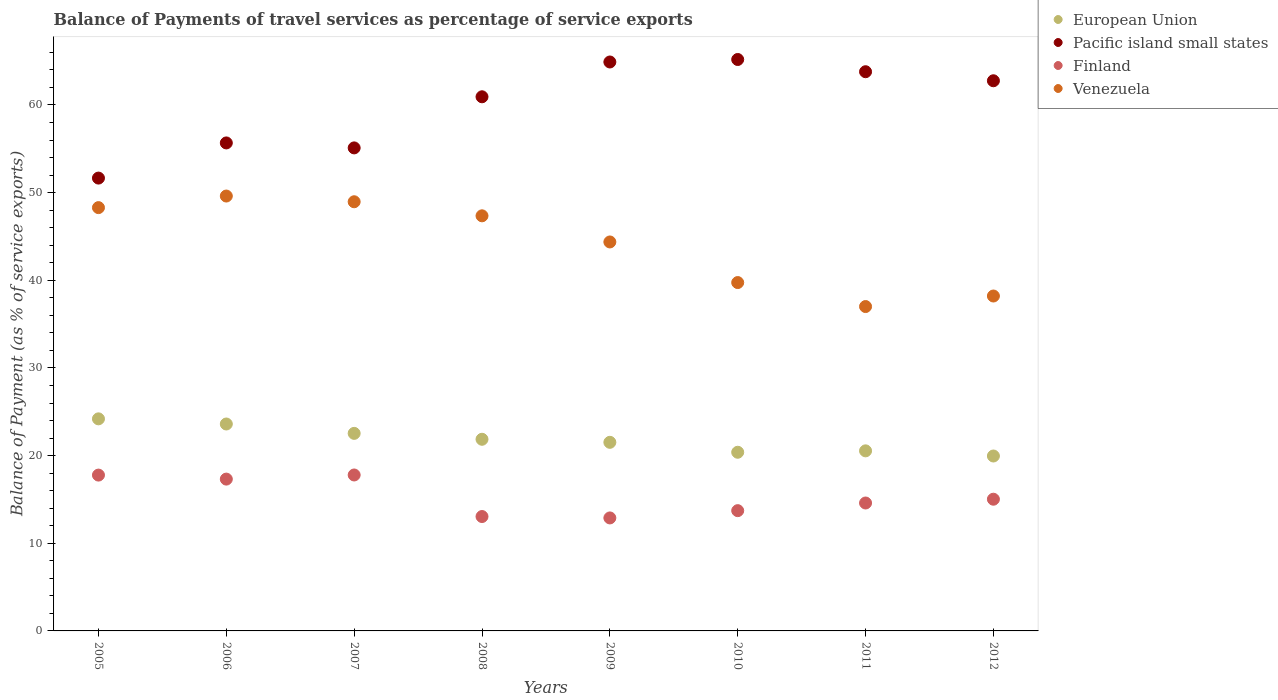How many different coloured dotlines are there?
Your answer should be very brief. 4. What is the balance of payments of travel services in European Union in 2011?
Ensure brevity in your answer.  20.54. Across all years, what is the maximum balance of payments of travel services in Venezuela?
Ensure brevity in your answer.  49.61. Across all years, what is the minimum balance of payments of travel services in Finland?
Offer a terse response. 12.89. What is the total balance of payments of travel services in Finland in the graph?
Ensure brevity in your answer.  122.17. What is the difference between the balance of payments of travel services in Venezuela in 2008 and that in 2009?
Your answer should be compact. 2.98. What is the difference between the balance of payments of travel services in European Union in 2011 and the balance of payments of travel services in Finland in 2012?
Keep it short and to the point. 5.52. What is the average balance of payments of travel services in Venezuela per year?
Ensure brevity in your answer.  44.19. In the year 2007, what is the difference between the balance of payments of travel services in Venezuela and balance of payments of travel services in European Union?
Your answer should be compact. 26.42. In how many years, is the balance of payments of travel services in European Union greater than 46 %?
Give a very brief answer. 0. What is the ratio of the balance of payments of travel services in European Union in 2008 to that in 2009?
Ensure brevity in your answer.  1.02. Is the balance of payments of travel services in Venezuela in 2007 less than that in 2012?
Your answer should be compact. No. What is the difference between the highest and the second highest balance of payments of travel services in European Union?
Your answer should be very brief. 0.59. What is the difference between the highest and the lowest balance of payments of travel services in European Union?
Provide a short and direct response. 4.24. Is the sum of the balance of payments of travel services in Pacific island small states in 2010 and 2012 greater than the maximum balance of payments of travel services in European Union across all years?
Your answer should be compact. Yes. Is the balance of payments of travel services in Pacific island small states strictly less than the balance of payments of travel services in European Union over the years?
Keep it short and to the point. No. Does the graph contain any zero values?
Offer a very short reply. No. Does the graph contain grids?
Provide a succinct answer. No. Where does the legend appear in the graph?
Ensure brevity in your answer.  Top right. What is the title of the graph?
Provide a short and direct response. Balance of Payments of travel services as percentage of service exports. Does "Uzbekistan" appear as one of the legend labels in the graph?
Your answer should be compact. No. What is the label or title of the Y-axis?
Offer a very short reply. Balance of Payment (as % of service exports). What is the Balance of Payment (as % of service exports) in European Union in 2005?
Your answer should be very brief. 24.19. What is the Balance of Payment (as % of service exports) in Pacific island small states in 2005?
Provide a short and direct response. 51.66. What is the Balance of Payment (as % of service exports) of Finland in 2005?
Provide a short and direct response. 17.78. What is the Balance of Payment (as % of service exports) in Venezuela in 2005?
Ensure brevity in your answer.  48.29. What is the Balance of Payment (as % of service exports) of European Union in 2006?
Provide a short and direct response. 23.61. What is the Balance of Payment (as % of service exports) of Pacific island small states in 2006?
Give a very brief answer. 55.67. What is the Balance of Payment (as % of service exports) in Finland in 2006?
Provide a succinct answer. 17.32. What is the Balance of Payment (as % of service exports) in Venezuela in 2006?
Make the answer very short. 49.61. What is the Balance of Payment (as % of service exports) in European Union in 2007?
Your answer should be compact. 22.54. What is the Balance of Payment (as % of service exports) of Pacific island small states in 2007?
Offer a very short reply. 55.1. What is the Balance of Payment (as % of service exports) of Finland in 2007?
Provide a short and direct response. 17.79. What is the Balance of Payment (as % of service exports) of Venezuela in 2007?
Ensure brevity in your answer.  48.96. What is the Balance of Payment (as % of service exports) of European Union in 2008?
Offer a terse response. 21.86. What is the Balance of Payment (as % of service exports) in Pacific island small states in 2008?
Ensure brevity in your answer.  60.94. What is the Balance of Payment (as % of service exports) of Finland in 2008?
Your answer should be very brief. 13.05. What is the Balance of Payment (as % of service exports) in Venezuela in 2008?
Provide a succinct answer. 47.36. What is the Balance of Payment (as % of service exports) in European Union in 2009?
Your response must be concise. 21.52. What is the Balance of Payment (as % of service exports) of Pacific island small states in 2009?
Your response must be concise. 64.91. What is the Balance of Payment (as % of service exports) in Finland in 2009?
Your answer should be very brief. 12.89. What is the Balance of Payment (as % of service exports) of Venezuela in 2009?
Keep it short and to the point. 44.37. What is the Balance of Payment (as % of service exports) in European Union in 2010?
Offer a very short reply. 20.38. What is the Balance of Payment (as % of service exports) in Pacific island small states in 2010?
Ensure brevity in your answer.  65.19. What is the Balance of Payment (as % of service exports) in Finland in 2010?
Ensure brevity in your answer.  13.72. What is the Balance of Payment (as % of service exports) of Venezuela in 2010?
Offer a terse response. 39.74. What is the Balance of Payment (as % of service exports) in European Union in 2011?
Give a very brief answer. 20.54. What is the Balance of Payment (as % of service exports) of Pacific island small states in 2011?
Ensure brevity in your answer.  63.8. What is the Balance of Payment (as % of service exports) in Finland in 2011?
Your answer should be compact. 14.59. What is the Balance of Payment (as % of service exports) of Venezuela in 2011?
Your response must be concise. 37.01. What is the Balance of Payment (as % of service exports) in European Union in 2012?
Your answer should be compact. 19.96. What is the Balance of Payment (as % of service exports) of Pacific island small states in 2012?
Give a very brief answer. 62.76. What is the Balance of Payment (as % of service exports) in Finland in 2012?
Your answer should be very brief. 15.03. What is the Balance of Payment (as % of service exports) in Venezuela in 2012?
Your answer should be compact. 38.21. Across all years, what is the maximum Balance of Payment (as % of service exports) in European Union?
Ensure brevity in your answer.  24.19. Across all years, what is the maximum Balance of Payment (as % of service exports) of Pacific island small states?
Provide a short and direct response. 65.19. Across all years, what is the maximum Balance of Payment (as % of service exports) of Finland?
Ensure brevity in your answer.  17.79. Across all years, what is the maximum Balance of Payment (as % of service exports) in Venezuela?
Give a very brief answer. 49.61. Across all years, what is the minimum Balance of Payment (as % of service exports) in European Union?
Make the answer very short. 19.96. Across all years, what is the minimum Balance of Payment (as % of service exports) in Pacific island small states?
Give a very brief answer. 51.66. Across all years, what is the minimum Balance of Payment (as % of service exports) of Finland?
Offer a terse response. 12.89. Across all years, what is the minimum Balance of Payment (as % of service exports) in Venezuela?
Give a very brief answer. 37.01. What is the total Balance of Payment (as % of service exports) in European Union in the graph?
Offer a very short reply. 174.6. What is the total Balance of Payment (as % of service exports) in Pacific island small states in the graph?
Your answer should be compact. 480.03. What is the total Balance of Payment (as % of service exports) of Finland in the graph?
Your answer should be very brief. 122.17. What is the total Balance of Payment (as % of service exports) of Venezuela in the graph?
Make the answer very short. 353.55. What is the difference between the Balance of Payment (as % of service exports) of European Union in 2005 and that in 2006?
Offer a very short reply. 0.59. What is the difference between the Balance of Payment (as % of service exports) in Pacific island small states in 2005 and that in 2006?
Your answer should be very brief. -4.01. What is the difference between the Balance of Payment (as % of service exports) of Finland in 2005 and that in 2006?
Your response must be concise. 0.46. What is the difference between the Balance of Payment (as % of service exports) of Venezuela in 2005 and that in 2006?
Your answer should be compact. -1.32. What is the difference between the Balance of Payment (as % of service exports) of European Union in 2005 and that in 2007?
Make the answer very short. 1.66. What is the difference between the Balance of Payment (as % of service exports) of Pacific island small states in 2005 and that in 2007?
Offer a very short reply. -3.44. What is the difference between the Balance of Payment (as % of service exports) in Finland in 2005 and that in 2007?
Provide a succinct answer. -0.01. What is the difference between the Balance of Payment (as % of service exports) in Venezuela in 2005 and that in 2007?
Ensure brevity in your answer.  -0.67. What is the difference between the Balance of Payment (as % of service exports) of European Union in 2005 and that in 2008?
Your answer should be very brief. 2.33. What is the difference between the Balance of Payment (as % of service exports) of Pacific island small states in 2005 and that in 2008?
Provide a short and direct response. -9.27. What is the difference between the Balance of Payment (as % of service exports) in Finland in 2005 and that in 2008?
Provide a succinct answer. 4.73. What is the difference between the Balance of Payment (as % of service exports) in Venezuela in 2005 and that in 2008?
Give a very brief answer. 0.93. What is the difference between the Balance of Payment (as % of service exports) in European Union in 2005 and that in 2009?
Offer a very short reply. 2.68. What is the difference between the Balance of Payment (as % of service exports) of Pacific island small states in 2005 and that in 2009?
Offer a very short reply. -13.24. What is the difference between the Balance of Payment (as % of service exports) in Finland in 2005 and that in 2009?
Your response must be concise. 4.89. What is the difference between the Balance of Payment (as % of service exports) of Venezuela in 2005 and that in 2009?
Offer a very short reply. 3.92. What is the difference between the Balance of Payment (as % of service exports) in European Union in 2005 and that in 2010?
Your answer should be very brief. 3.81. What is the difference between the Balance of Payment (as % of service exports) in Pacific island small states in 2005 and that in 2010?
Offer a very short reply. -13.53. What is the difference between the Balance of Payment (as % of service exports) in Finland in 2005 and that in 2010?
Provide a short and direct response. 4.06. What is the difference between the Balance of Payment (as % of service exports) in Venezuela in 2005 and that in 2010?
Provide a short and direct response. 8.55. What is the difference between the Balance of Payment (as % of service exports) in European Union in 2005 and that in 2011?
Keep it short and to the point. 3.65. What is the difference between the Balance of Payment (as % of service exports) in Pacific island small states in 2005 and that in 2011?
Offer a very short reply. -12.13. What is the difference between the Balance of Payment (as % of service exports) of Finland in 2005 and that in 2011?
Keep it short and to the point. 3.18. What is the difference between the Balance of Payment (as % of service exports) in Venezuela in 2005 and that in 2011?
Your answer should be very brief. 11.29. What is the difference between the Balance of Payment (as % of service exports) of European Union in 2005 and that in 2012?
Provide a short and direct response. 4.24. What is the difference between the Balance of Payment (as % of service exports) in Pacific island small states in 2005 and that in 2012?
Make the answer very short. -11.1. What is the difference between the Balance of Payment (as % of service exports) of Finland in 2005 and that in 2012?
Keep it short and to the point. 2.75. What is the difference between the Balance of Payment (as % of service exports) in Venezuela in 2005 and that in 2012?
Make the answer very short. 10.08. What is the difference between the Balance of Payment (as % of service exports) of European Union in 2006 and that in 2007?
Your answer should be very brief. 1.07. What is the difference between the Balance of Payment (as % of service exports) of Pacific island small states in 2006 and that in 2007?
Your answer should be very brief. 0.57. What is the difference between the Balance of Payment (as % of service exports) of Finland in 2006 and that in 2007?
Provide a short and direct response. -0.47. What is the difference between the Balance of Payment (as % of service exports) of Venezuela in 2006 and that in 2007?
Offer a terse response. 0.65. What is the difference between the Balance of Payment (as % of service exports) in European Union in 2006 and that in 2008?
Give a very brief answer. 1.74. What is the difference between the Balance of Payment (as % of service exports) in Pacific island small states in 2006 and that in 2008?
Your answer should be compact. -5.26. What is the difference between the Balance of Payment (as % of service exports) of Finland in 2006 and that in 2008?
Keep it short and to the point. 4.27. What is the difference between the Balance of Payment (as % of service exports) of Venezuela in 2006 and that in 2008?
Ensure brevity in your answer.  2.26. What is the difference between the Balance of Payment (as % of service exports) in European Union in 2006 and that in 2009?
Your response must be concise. 2.09. What is the difference between the Balance of Payment (as % of service exports) in Pacific island small states in 2006 and that in 2009?
Ensure brevity in your answer.  -9.23. What is the difference between the Balance of Payment (as % of service exports) of Finland in 2006 and that in 2009?
Offer a terse response. 4.43. What is the difference between the Balance of Payment (as % of service exports) of Venezuela in 2006 and that in 2009?
Offer a very short reply. 5.24. What is the difference between the Balance of Payment (as % of service exports) of European Union in 2006 and that in 2010?
Ensure brevity in your answer.  3.22. What is the difference between the Balance of Payment (as % of service exports) of Pacific island small states in 2006 and that in 2010?
Your response must be concise. -9.52. What is the difference between the Balance of Payment (as % of service exports) of Finland in 2006 and that in 2010?
Your answer should be compact. 3.6. What is the difference between the Balance of Payment (as % of service exports) in Venezuela in 2006 and that in 2010?
Offer a very short reply. 9.87. What is the difference between the Balance of Payment (as % of service exports) in European Union in 2006 and that in 2011?
Offer a very short reply. 3.06. What is the difference between the Balance of Payment (as % of service exports) of Pacific island small states in 2006 and that in 2011?
Keep it short and to the point. -8.12. What is the difference between the Balance of Payment (as % of service exports) of Finland in 2006 and that in 2011?
Keep it short and to the point. 2.73. What is the difference between the Balance of Payment (as % of service exports) of Venezuela in 2006 and that in 2011?
Make the answer very short. 12.61. What is the difference between the Balance of Payment (as % of service exports) in European Union in 2006 and that in 2012?
Your response must be concise. 3.65. What is the difference between the Balance of Payment (as % of service exports) of Pacific island small states in 2006 and that in 2012?
Keep it short and to the point. -7.09. What is the difference between the Balance of Payment (as % of service exports) in Finland in 2006 and that in 2012?
Keep it short and to the point. 2.29. What is the difference between the Balance of Payment (as % of service exports) of Venezuela in 2006 and that in 2012?
Provide a short and direct response. 11.41. What is the difference between the Balance of Payment (as % of service exports) in European Union in 2007 and that in 2008?
Give a very brief answer. 0.67. What is the difference between the Balance of Payment (as % of service exports) of Pacific island small states in 2007 and that in 2008?
Offer a terse response. -5.83. What is the difference between the Balance of Payment (as % of service exports) in Finland in 2007 and that in 2008?
Your answer should be very brief. 4.74. What is the difference between the Balance of Payment (as % of service exports) in Venezuela in 2007 and that in 2008?
Your response must be concise. 1.6. What is the difference between the Balance of Payment (as % of service exports) in European Union in 2007 and that in 2009?
Provide a succinct answer. 1.02. What is the difference between the Balance of Payment (as % of service exports) of Pacific island small states in 2007 and that in 2009?
Give a very brief answer. -9.8. What is the difference between the Balance of Payment (as % of service exports) of Finland in 2007 and that in 2009?
Provide a succinct answer. 4.9. What is the difference between the Balance of Payment (as % of service exports) in Venezuela in 2007 and that in 2009?
Your answer should be very brief. 4.59. What is the difference between the Balance of Payment (as % of service exports) in European Union in 2007 and that in 2010?
Ensure brevity in your answer.  2.15. What is the difference between the Balance of Payment (as % of service exports) in Pacific island small states in 2007 and that in 2010?
Ensure brevity in your answer.  -10.09. What is the difference between the Balance of Payment (as % of service exports) of Finland in 2007 and that in 2010?
Offer a terse response. 4.07. What is the difference between the Balance of Payment (as % of service exports) of Venezuela in 2007 and that in 2010?
Give a very brief answer. 9.22. What is the difference between the Balance of Payment (as % of service exports) in European Union in 2007 and that in 2011?
Offer a very short reply. 1.99. What is the difference between the Balance of Payment (as % of service exports) of Pacific island small states in 2007 and that in 2011?
Provide a short and direct response. -8.69. What is the difference between the Balance of Payment (as % of service exports) of Finland in 2007 and that in 2011?
Keep it short and to the point. 3.2. What is the difference between the Balance of Payment (as % of service exports) in Venezuela in 2007 and that in 2011?
Ensure brevity in your answer.  11.96. What is the difference between the Balance of Payment (as % of service exports) of European Union in 2007 and that in 2012?
Provide a short and direct response. 2.58. What is the difference between the Balance of Payment (as % of service exports) in Pacific island small states in 2007 and that in 2012?
Provide a short and direct response. -7.66. What is the difference between the Balance of Payment (as % of service exports) of Finland in 2007 and that in 2012?
Your answer should be compact. 2.76. What is the difference between the Balance of Payment (as % of service exports) of Venezuela in 2007 and that in 2012?
Your answer should be compact. 10.75. What is the difference between the Balance of Payment (as % of service exports) of European Union in 2008 and that in 2009?
Provide a short and direct response. 0.35. What is the difference between the Balance of Payment (as % of service exports) in Pacific island small states in 2008 and that in 2009?
Your answer should be compact. -3.97. What is the difference between the Balance of Payment (as % of service exports) of Finland in 2008 and that in 2009?
Provide a succinct answer. 0.16. What is the difference between the Balance of Payment (as % of service exports) in Venezuela in 2008 and that in 2009?
Keep it short and to the point. 2.98. What is the difference between the Balance of Payment (as % of service exports) in European Union in 2008 and that in 2010?
Offer a terse response. 1.48. What is the difference between the Balance of Payment (as % of service exports) of Pacific island small states in 2008 and that in 2010?
Ensure brevity in your answer.  -4.25. What is the difference between the Balance of Payment (as % of service exports) of Finland in 2008 and that in 2010?
Your answer should be very brief. -0.67. What is the difference between the Balance of Payment (as % of service exports) in Venezuela in 2008 and that in 2010?
Your answer should be compact. 7.61. What is the difference between the Balance of Payment (as % of service exports) of European Union in 2008 and that in 2011?
Offer a very short reply. 1.32. What is the difference between the Balance of Payment (as % of service exports) in Pacific island small states in 2008 and that in 2011?
Ensure brevity in your answer.  -2.86. What is the difference between the Balance of Payment (as % of service exports) in Finland in 2008 and that in 2011?
Your answer should be very brief. -1.54. What is the difference between the Balance of Payment (as % of service exports) of Venezuela in 2008 and that in 2011?
Make the answer very short. 10.35. What is the difference between the Balance of Payment (as % of service exports) in European Union in 2008 and that in 2012?
Your answer should be very brief. 1.91. What is the difference between the Balance of Payment (as % of service exports) of Pacific island small states in 2008 and that in 2012?
Make the answer very short. -1.83. What is the difference between the Balance of Payment (as % of service exports) of Finland in 2008 and that in 2012?
Provide a succinct answer. -1.98. What is the difference between the Balance of Payment (as % of service exports) of Venezuela in 2008 and that in 2012?
Offer a very short reply. 9.15. What is the difference between the Balance of Payment (as % of service exports) in European Union in 2009 and that in 2010?
Make the answer very short. 1.13. What is the difference between the Balance of Payment (as % of service exports) in Pacific island small states in 2009 and that in 2010?
Keep it short and to the point. -0.28. What is the difference between the Balance of Payment (as % of service exports) in Finland in 2009 and that in 2010?
Keep it short and to the point. -0.83. What is the difference between the Balance of Payment (as % of service exports) of Venezuela in 2009 and that in 2010?
Provide a succinct answer. 4.63. What is the difference between the Balance of Payment (as % of service exports) of European Union in 2009 and that in 2011?
Offer a very short reply. 0.97. What is the difference between the Balance of Payment (as % of service exports) in Pacific island small states in 2009 and that in 2011?
Make the answer very short. 1.11. What is the difference between the Balance of Payment (as % of service exports) of Finland in 2009 and that in 2011?
Ensure brevity in your answer.  -1.7. What is the difference between the Balance of Payment (as % of service exports) of Venezuela in 2009 and that in 2011?
Offer a terse response. 7.37. What is the difference between the Balance of Payment (as % of service exports) in European Union in 2009 and that in 2012?
Keep it short and to the point. 1.56. What is the difference between the Balance of Payment (as % of service exports) of Pacific island small states in 2009 and that in 2012?
Your answer should be compact. 2.14. What is the difference between the Balance of Payment (as % of service exports) of Finland in 2009 and that in 2012?
Give a very brief answer. -2.13. What is the difference between the Balance of Payment (as % of service exports) of Venezuela in 2009 and that in 2012?
Your response must be concise. 6.17. What is the difference between the Balance of Payment (as % of service exports) in European Union in 2010 and that in 2011?
Your response must be concise. -0.16. What is the difference between the Balance of Payment (as % of service exports) of Pacific island small states in 2010 and that in 2011?
Offer a terse response. 1.4. What is the difference between the Balance of Payment (as % of service exports) in Finland in 2010 and that in 2011?
Provide a short and direct response. -0.87. What is the difference between the Balance of Payment (as % of service exports) of Venezuela in 2010 and that in 2011?
Ensure brevity in your answer.  2.74. What is the difference between the Balance of Payment (as % of service exports) in European Union in 2010 and that in 2012?
Give a very brief answer. 0.43. What is the difference between the Balance of Payment (as % of service exports) in Pacific island small states in 2010 and that in 2012?
Give a very brief answer. 2.43. What is the difference between the Balance of Payment (as % of service exports) of Finland in 2010 and that in 2012?
Provide a succinct answer. -1.3. What is the difference between the Balance of Payment (as % of service exports) of Venezuela in 2010 and that in 2012?
Your response must be concise. 1.53. What is the difference between the Balance of Payment (as % of service exports) of European Union in 2011 and that in 2012?
Offer a terse response. 0.59. What is the difference between the Balance of Payment (as % of service exports) in Pacific island small states in 2011 and that in 2012?
Your response must be concise. 1.03. What is the difference between the Balance of Payment (as % of service exports) in Finland in 2011 and that in 2012?
Your answer should be very brief. -0.43. What is the difference between the Balance of Payment (as % of service exports) in Venezuela in 2011 and that in 2012?
Your response must be concise. -1.2. What is the difference between the Balance of Payment (as % of service exports) in European Union in 2005 and the Balance of Payment (as % of service exports) in Pacific island small states in 2006?
Keep it short and to the point. -31.48. What is the difference between the Balance of Payment (as % of service exports) of European Union in 2005 and the Balance of Payment (as % of service exports) of Finland in 2006?
Your response must be concise. 6.87. What is the difference between the Balance of Payment (as % of service exports) in European Union in 2005 and the Balance of Payment (as % of service exports) in Venezuela in 2006?
Offer a terse response. -25.42. What is the difference between the Balance of Payment (as % of service exports) in Pacific island small states in 2005 and the Balance of Payment (as % of service exports) in Finland in 2006?
Provide a succinct answer. 34.34. What is the difference between the Balance of Payment (as % of service exports) of Pacific island small states in 2005 and the Balance of Payment (as % of service exports) of Venezuela in 2006?
Provide a short and direct response. 2.05. What is the difference between the Balance of Payment (as % of service exports) in Finland in 2005 and the Balance of Payment (as % of service exports) in Venezuela in 2006?
Your response must be concise. -31.83. What is the difference between the Balance of Payment (as % of service exports) of European Union in 2005 and the Balance of Payment (as % of service exports) of Pacific island small states in 2007?
Provide a succinct answer. -30.91. What is the difference between the Balance of Payment (as % of service exports) of European Union in 2005 and the Balance of Payment (as % of service exports) of Finland in 2007?
Make the answer very short. 6.4. What is the difference between the Balance of Payment (as % of service exports) in European Union in 2005 and the Balance of Payment (as % of service exports) in Venezuela in 2007?
Your answer should be very brief. -24.77. What is the difference between the Balance of Payment (as % of service exports) in Pacific island small states in 2005 and the Balance of Payment (as % of service exports) in Finland in 2007?
Ensure brevity in your answer.  33.87. What is the difference between the Balance of Payment (as % of service exports) of Pacific island small states in 2005 and the Balance of Payment (as % of service exports) of Venezuela in 2007?
Make the answer very short. 2.7. What is the difference between the Balance of Payment (as % of service exports) in Finland in 2005 and the Balance of Payment (as % of service exports) in Venezuela in 2007?
Offer a very short reply. -31.18. What is the difference between the Balance of Payment (as % of service exports) of European Union in 2005 and the Balance of Payment (as % of service exports) of Pacific island small states in 2008?
Your response must be concise. -36.74. What is the difference between the Balance of Payment (as % of service exports) in European Union in 2005 and the Balance of Payment (as % of service exports) in Finland in 2008?
Keep it short and to the point. 11.14. What is the difference between the Balance of Payment (as % of service exports) in European Union in 2005 and the Balance of Payment (as % of service exports) in Venezuela in 2008?
Your answer should be very brief. -23.16. What is the difference between the Balance of Payment (as % of service exports) of Pacific island small states in 2005 and the Balance of Payment (as % of service exports) of Finland in 2008?
Ensure brevity in your answer.  38.61. What is the difference between the Balance of Payment (as % of service exports) in Pacific island small states in 2005 and the Balance of Payment (as % of service exports) in Venezuela in 2008?
Ensure brevity in your answer.  4.3. What is the difference between the Balance of Payment (as % of service exports) of Finland in 2005 and the Balance of Payment (as % of service exports) of Venezuela in 2008?
Your answer should be compact. -29.58. What is the difference between the Balance of Payment (as % of service exports) of European Union in 2005 and the Balance of Payment (as % of service exports) of Pacific island small states in 2009?
Provide a short and direct response. -40.71. What is the difference between the Balance of Payment (as % of service exports) in European Union in 2005 and the Balance of Payment (as % of service exports) in Finland in 2009?
Ensure brevity in your answer.  11.3. What is the difference between the Balance of Payment (as % of service exports) in European Union in 2005 and the Balance of Payment (as % of service exports) in Venezuela in 2009?
Keep it short and to the point. -20.18. What is the difference between the Balance of Payment (as % of service exports) in Pacific island small states in 2005 and the Balance of Payment (as % of service exports) in Finland in 2009?
Your response must be concise. 38.77. What is the difference between the Balance of Payment (as % of service exports) in Pacific island small states in 2005 and the Balance of Payment (as % of service exports) in Venezuela in 2009?
Offer a terse response. 7.29. What is the difference between the Balance of Payment (as % of service exports) in Finland in 2005 and the Balance of Payment (as % of service exports) in Venezuela in 2009?
Provide a short and direct response. -26.6. What is the difference between the Balance of Payment (as % of service exports) of European Union in 2005 and the Balance of Payment (as % of service exports) of Pacific island small states in 2010?
Your response must be concise. -41. What is the difference between the Balance of Payment (as % of service exports) in European Union in 2005 and the Balance of Payment (as % of service exports) in Finland in 2010?
Make the answer very short. 10.47. What is the difference between the Balance of Payment (as % of service exports) in European Union in 2005 and the Balance of Payment (as % of service exports) in Venezuela in 2010?
Keep it short and to the point. -15.55. What is the difference between the Balance of Payment (as % of service exports) of Pacific island small states in 2005 and the Balance of Payment (as % of service exports) of Finland in 2010?
Give a very brief answer. 37.94. What is the difference between the Balance of Payment (as % of service exports) in Pacific island small states in 2005 and the Balance of Payment (as % of service exports) in Venezuela in 2010?
Keep it short and to the point. 11.92. What is the difference between the Balance of Payment (as % of service exports) in Finland in 2005 and the Balance of Payment (as % of service exports) in Venezuela in 2010?
Offer a terse response. -21.96. What is the difference between the Balance of Payment (as % of service exports) of European Union in 2005 and the Balance of Payment (as % of service exports) of Pacific island small states in 2011?
Your answer should be compact. -39.6. What is the difference between the Balance of Payment (as % of service exports) of European Union in 2005 and the Balance of Payment (as % of service exports) of Finland in 2011?
Provide a succinct answer. 9.6. What is the difference between the Balance of Payment (as % of service exports) in European Union in 2005 and the Balance of Payment (as % of service exports) in Venezuela in 2011?
Offer a terse response. -12.81. What is the difference between the Balance of Payment (as % of service exports) of Pacific island small states in 2005 and the Balance of Payment (as % of service exports) of Finland in 2011?
Ensure brevity in your answer.  37.07. What is the difference between the Balance of Payment (as % of service exports) in Pacific island small states in 2005 and the Balance of Payment (as % of service exports) in Venezuela in 2011?
Keep it short and to the point. 14.66. What is the difference between the Balance of Payment (as % of service exports) of Finland in 2005 and the Balance of Payment (as % of service exports) of Venezuela in 2011?
Keep it short and to the point. -19.23. What is the difference between the Balance of Payment (as % of service exports) of European Union in 2005 and the Balance of Payment (as % of service exports) of Pacific island small states in 2012?
Give a very brief answer. -38.57. What is the difference between the Balance of Payment (as % of service exports) of European Union in 2005 and the Balance of Payment (as % of service exports) of Finland in 2012?
Make the answer very short. 9.17. What is the difference between the Balance of Payment (as % of service exports) of European Union in 2005 and the Balance of Payment (as % of service exports) of Venezuela in 2012?
Offer a very short reply. -14.01. What is the difference between the Balance of Payment (as % of service exports) in Pacific island small states in 2005 and the Balance of Payment (as % of service exports) in Finland in 2012?
Your answer should be compact. 36.64. What is the difference between the Balance of Payment (as % of service exports) of Pacific island small states in 2005 and the Balance of Payment (as % of service exports) of Venezuela in 2012?
Your response must be concise. 13.45. What is the difference between the Balance of Payment (as % of service exports) of Finland in 2005 and the Balance of Payment (as % of service exports) of Venezuela in 2012?
Make the answer very short. -20.43. What is the difference between the Balance of Payment (as % of service exports) in European Union in 2006 and the Balance of Payment (as % of service exports) in Pacific island small states in 2007?
Keep it short and to the point. -31.5. What is the difference between the Balance of Payment (as % of service exports) of European Union in 2006 and the Balance of Payment (as % of service exports) of Finland in 2007?
Your response must be concise. 5.82. What is the difference between the Balance of Payment (as % of service exports) in European Union in 2006 and the Balance of Payment (as % of service exports) in Venezuela in 2007?
Offer a very short reply. -25.35. What is the difference between the Balance of Payment (as % of service exports) of Pacific island small states in 2006 and the Balance of Payment (as % of service exports) of Finland in 2007?
Make the answer very short. 37.88. What is the difference between the Balance of Payment (as % of service exports) in Pacific island small states in 2006 and the Balance of Payment (as % of service exports) in Venezuela in 2007?
Give a very brief answer. 6.71. What is the difference between the Balance of Payment (as % of service exports) in Finland in 2006 and the Balance of Payment (as % of service exports) in Venezuela in 2007?
Your answer should be very brief. -31.64. What is the difference between the Balance of Payment (as % of service exports) of European Union in 2006 and the Balance of Payment (as % of service exports) of Pacific island small states in 2008?
Offer a very short reply. -37.33. What is the difference between the Balance of Payment (as % of service exports) of European Union in 2006 and the Balance of Payment (as % of service exports) of Finland in 2008?
Offer a terse response. 10.56. What is the difference between the Balance of Payment (as % of service exports) in European Union in 2006 and the Balance of Payment (as % of service exports) in Venezuela in 2008?
Provide a short and direct response. -23.75. What is the difference between the Balance of Payment (as % of service exports) in Pacific island small states in 2006 and the Balance of Payment (as % of service exports) in Finland in 2008?
Keep it short and to the point. 42.62. What is the difference between the Balance of Payment (as % of service exports) of Pacific island small states in 2006 and the Balance of Payment (as % of service exports) of Venezuela in 2008?
Ensure brevity in your answer.  8.32. What is the difference between the Balance of Payment (as % of service exports) of Finland in 2006 and the Balance of Payment (as % of service exports) of Venezuela in 2008?
Offer a very short reply. -30.04. What is the difference between the Balance of Payment (as % of service exports) of European Union in 2006 and the Balance of Payment (as % of service exports) of Pacific island small states in 2009?
Make the answer very short. -41.3. What is the difference between the Balance of Payment (as % of service exports) of European Union in 2006 and the Balance of Payment (as % of service exports) of Finland in 2009?
Make the answer very short. 10.72. What is the difference between the Balance of Payment (as % of service exports) in European Union in 2006 and the Balance of Payment (as % of service exports) in Venezuela in 2009?
Make the answer very short. -20.77. What is the difference between the Balance of Payment (as % of service exports) of Pacific island small states in 2006 and the Balance of Payment (as % of service exports) of Finland in 2009?
Offer a terse response. 42.78. What is the difference between the Balance of Payment (as % of service exports) in Pacific island small states in 2006 and the Balance of Payment (as % of service exports) in Venezuela in 2009?
Offer a terse response. 11.3. What is the difference between the Balance of Payment (as % of service exports) in Finland in 2006 and the Balance of Payment (as % of service exports) in Venezuela in 2009?
Your answer should be compact. -27.05. What is the difference between the Balance of Payment (as % of service exports) of European Union in 2006 and the Balance of Payment (as % of service exports) of Pacific island small states in 2010?
Provide a succinct answer. -41.58. What is the difference between the Balance of Payment (as % of service exports) of European Union in 2006 and the Balance of Payment (as % of service exports) of Finland in 2010?
Offer a very short reply. 9.89. What is the difference between the Balance of Payment (as % of service exports) of European Union in 2006 and the Balance of Payment (as % of service exports) of Venezuela in 2010?
Ensure brevity in your answer.  -16.14. What is the difference between the Balance of Payment (as % of service exports) in Pacific island small states in 2006 and the Balance of Payment (as % of service exports) in Finland in 2010?
Your answer should be very brief. 41.95. What is the difference between the Balance of Payment (as % of service exports) in Pacific island small states in 2006 and the Balance of Payment (as % of service exports) in Venezuela in 2010?
Ensure brevity in your answer.  15.93. What is the difference between the Balance of Payment (as % of service exports) of Finland in 2006 and the Balance of Payment (as % of service exports) of Venezuela in 2010?
Your response must be concise. -22.42. What is the difference between the Balance of Payment (as % of service exports) of European Union in 2006 and the Balance of Payment (as % of service exports) of Pacific island small states in 2011?
Your answer should be compact. -40.19. What is the difference between the Balance of Payment (as % of service exports) in European Union in 2006 and the Balance of Payment (as % of service exports) in Finland in 2011?
Offer a very short reply. 9.01. What is the difference between the Balance of Payment (as % of service exports) in European Union in 2006 and the Balance of Payment (as % of service exports) in Venezuela in 2011?
Offer a terse response. -13.4. What is the difference between the Balance of Payment (as % of service exports) of Pacific island small states in 2006 and the Balance of Payment (as % of service exports) of Finland in 2011?
Make the answer very short. 41.08. What is the difference between the Balance of Payment (as % of service exports) of Pacific island small states in 2006 and the Balance of Payment (as % of service exports) of Venezuela in 2011?
Make the answer very short. 18.67. What is the difference between the Balance of Payment (as % of service exports) in Finland in 2006 and the Balance of Payment (as % of service exports) in Venezuela in 2011?
Make the answer very short. -19.69. What is the difference between the Balance of Payment (as % of service exports) in European Union in 2006 and the Balance of Payment (as % of service exports) in Pacific island small states in 2012?
Provide a short and direct response. -39.16. What is the difference between the Balance of Payment (as % of service exports) in European Union in 2006 and the Balance of Payment (as % of service exports) in Finland in 2012?
Offer a very short reply. 8.58. What is the difference between the Balance of Payment (as % of service exports) in European Union in 2006 and the Balance of Payment (as % of service exports) in Venezuela in 2012?
Ensure brevity in your answer.  -14.6. What is the difference between the Balance of Payment (as % of service exports) in Pacific island small states in 2006 and the Balance of Payment (as % of service exports) in Finland in 2012?
Keep it short and to the point. 40.65. What is the difference between the Balance of Payment (as % of service exports) of Pacific island small states in 2006 and the Balance of Payment (as % of service exports) of Venezuela in 2012?
Keep it short and to the point. 17.46. What is the difference between the Balance of Payment (as % of service exports) in Finland in 2006 and the Balance of Payment (as % of service exports) in Venezuela in 2012?
Provide a succinct answer. -20.89. What is the difference between the Balance of Payment (as % of service exports) in European Union in 2007 and the Balance of Payment (as % of service exports) in Pacific island small states in 2008?
Give a very brief answer. -38.4. What is the difference between the Balance of Payment (as % of service exports) in European Union in 2007 and the Balance of Payment (as % of service exports) in Finland in 2008?
Offer a very short reply. 9.49. What is the difference between the Balance of Payment (as % of service exports) of European Union in 2007 and the Balance of Payment (as % of service exports) of Venezuela in 2008?
Provide a short and direct response. -24.82. What is the difference between the Balance of Payment (as % of service exports) in Pacific island small states in 2007 and the Balance of Payment (as % of service exports) in Finland in 2008?
Give a very brief answer. 42.05. What is the difference between the Balance of Payment (as % of service exports) of Pacific island small states in 2007 and the Balance of Payment (as % of service exports) of Venezuela in 2008?
Make the answer very short. 7.75. What is the difference between the Balance of Payment (as % of service exports) in Finland in 2007 and the Balance of Payment (as % of service exports) in Venezuela in 2008?
Offer a terse response. -29.57. What is the difference between the Balance of Payment (as % of service exports) in European Union in 2007 and the Balance of Payment (as % of service exports) in Pacific island small states in 2009?
Give a very brief answer. -42.37. What is the difference between the Balance of Payment (as % of service exports) of European Union in 2007 and the Balance of Payment (as % of service exports) of Finland in 2009?
Ensure brevity in your answer.  9.65. What is the difference between the Balance of Payment (as % of service exports) of European Union in 2007 and the Balance of Payment (as % of service exports) of Venezuela in 2009?
Keep it short and to the point. -21.84. What is the difference between the Balance of Payment (as % of service exports) in Pacific island small states in 2007 and the Balance of Payment (as % of service exports) in Finland in 2009?
Keep it short and to the point. 42.21. What is the difference between the Balance of Payment (as % of service exports) in Pacific island small states in 2007 and the Balance of Payment (as % of service exports) in Venezuela in 2009?
Ensure brevity in your answer.  10.73. What is the difference between the Balance of Payment (as % of service exports) in Finland in 2007 and the Balance of Payment (as % of service exports) in Venezuela in 2009?
Offer a very short reply. -26.58. What is the difference between the Balance of Payment (as % of service exports) of European Union in 2007 and the Balance of Payment (as % of service exports) of Pacific island small states in 2010?
Make the answer very short. -42.65. What is the difference between the Balance of Payment (as % of service exports) in European Union in 2007 and the Balance of Payment (as % of service exports) in Finland in 2010?
Your response must be concise. 8.82. What is the difference between the Balance of Payment (as % of service exports) of European Union in 2007 and the Balance of Payment (as % of service exports) of Venezuela in 2010?
Offer a very short reply. -17.21. What is the difference between the Balance of Payment (as % of service exports) of Pacific island small states in 2007 and the Balance of Payment (as % of service exports) of Finland in 2010?
Make the answer very short. 41.38. What is the difference between the Balance of Payment (as % of service exports) of Pacific island small states in 2007 and the Balance of Payment (as % of service exports) of Venezuela in 2010?
Your response must be concise. 15.36. What is the difference between the Balance of Payment (as % of service exports) of Finland in 2007 and the Balance of Payment (as % of service exports) of Venezuela in 2010?
Give a very brief answer. -21.95. What is the difference between the Balance of Payment (as % of service exports) in European Union in 2007 and the Balance of Payment (as % of service exports) in Pacific island small states in 2011?
Give a very brief answer. -41.26. What is the difference between the Balance of Payment (as % of service exports) in European Union in 2007 and the Balance of Payment (as % of service exports) in Finland in 2011?
Your answer should be very brief. 7.94. What is the difference between the Balance of Payment (as % of service exports) in European Union in 2007 and the Balance of Payment (as % of service exports) in Venezuela in 2011?
Your answer should be compact. -14.47. What is the difference between the Balance of Payment (as % of service exports) in Pacific island small states in 2007 and the Balance of Payment (as % of service exports) in Finland in 2011?
Your response must be concise. 40.51. What is the difference between the Balance of Payment (as % of service exports) of Pacific island small states in 2007 and the Balance of Payment (as % of service exports) of Venezuela in 2011?
Offer a terse response. 18.1. What is the difference between the Balance of Payment (as % of service exports) of Finland in 2007 and the Balance of Payment (as % of service exports) of Venezuela in 2011?
Give a very brief answer. -19.22. What is the difference between the Balance of Payment (as % of service exports) in European Union in 2007 and the Balance of Payment (as % of service exports) in Pacific island small states in 2012?
Offer a very short reply. -40.23. What is the difference between the Balance of Payment (as % of service exports) in European Union in 2007 and the Balance of Payment (as % of service exports) in Finland in 2012?
Offer a terse response. 7.51. What is the difference between the Balance of Payment (as % of service exports) in European Union in 2007 and the Balance of Payment (as % of service exports) in Venezuela in 2012?
Ensure brevity in your answer.  -15.67. What is the difference between the Balance of Payment (as % of service exports) in Pacific island small states in 2007 and the Balance of Payment (as % of service exports) in Finland in 2012?
Your response must be concise. 40.08. What is the difference between the Balance of Payment (as % of service exports) of Pacific island small states in 2007 and the Balance of Payment (as % of service exports) of Venezuela in 2012?
Offer a terse response. 16.9. What is the difference between the Balance of Payment (as % of service exports) in Finland in 2007 and the Balance of Payment (as % of service exports) in Venezuela in 2012?
Your answer should be compact. -20.42. What is the difference between the Balance of Payment (as % of service exports) in European Union in 2008 and the Balance of Payment (as % of service exports) in Pacific island small states in 2009?
Your answer should be compact. -43.04. What is the difference between the Balance of Payment (as % of service exports) of European Union in 2008 and the Balance of Payment (as % of service exports) of Finland in 2009?
Give a very brief answer. 8.97. What is the difference between the Balance of Payment (as % of service exports) in European Union in 2008 and the Balance of Payment (as % of service exports) in Venezuela in 2009?
Provide a short and direct response. -22.51. What is the difference between the Balance of Payment (as % of service exports) in Pacific island small states in 2008 and the Balance of Payment (as % of service exports) in Finland in 2009?
Provide a succinct answer. 48.04. What is the difference between the Balance of Payment (as % of service exports) in Pacific island small states in 2008 and the Balance of Payment (as % of service exports) in Venezuela in 2009?
Offer a very short reply. 16.56. What is the difference between the Balance of Payment (as % of service exports) of Finland in 2008 and the Balance of Payment (as % of service exports) of Venezuela in 2009?
Your answer should be very brief. -31.32. What is the difference between the Balance of Payment (as % of service exports) in European Union in 2008 and the Balance of Payment (as % of service exports) in Pacific island small states in 2010?
Keep it short and to the point. -43.33. What is the difference between the Balance of Payment (as % of service exports) in European Union in 2008 and the Balance of Payment (as % of service exports) in Finland in 2010?
Keep it short and to the point. 8.14. What is the difference between the Balance of Payment (as % of service exports) of European Union in 2008 and the Balance of Payment (as % of service exports) of Venezuela in 2010?
Provide a short and direct response. -17.88. What is the difference between the Balance of Payment (as % of service exports) in Pacific island small states in 2008 and the Balance of Payment (as % of service exports) in Finland in 2010?
Give a very brief answer. 47.21. What is the difference between the Balance of Payment (as % of service exports) of Pacific island small states in 2008 and the Balance of Payment (as % of service exports) of Venezuela in 2010?
Make the answer very short. 21.19. What is the difference between the Balance of Payment (as % of service exports) of Finland in 2008 and the Balance of Payment (as % of service exports) of Venezuela in 2010?
Your answer should be compact. -26.69. What is the difference between the Balance of Payment (as % of service exports) in European Union in 2008 and the Balance of Payment (as % of service exports) in Pacific island small states in 2011?
Offer a terse response. -41.93. What is the difference between the Balance of Payment (as % of service exports) of European Union in 2008 and the Balance of Payment (as % of service exports) of Finland in 2011?
Offer a terse response. 7.27. What is the difference between the Balance of Payment (as % of service exports) of European Union in 2008 and the Balance of Payment (as % of service exports) of Venezuela in 2011?
Offer a very short reply. -15.14. What is the difference between the Balance of Payment (as % of service exports) of Pacific island small states in 2008 and the Balance of Payment (as % of service exports) of Finland in 2011?
Provide a succinct answer. 46.34. What is the difference between the Balance of Payment (as % of service exports) of Pacific island small states in 2008 and the Balance of Payment (as % of service exports) of Venezuela in 2011?
Keep it short and to the point. 23.93. What is the difference between the Balance of Payment (as % of service exports) in Finland in 2008 and the Balance of Payment (as % of service exports) in Venezuela in 2011?
Your response must be concise. -23.96. What is the difference between the Balance of Payment (as % of service exports) of European Union in 2008 and the Balance of Payment (as % of service exports) of Pacific island small states in 2012?
Provide a succinct answer. -40.9. What is the difference between the Balance of Payment (as % of service exports) of European Union in 2008 and the Balance of Payment (as % of service exports) of Finland in 2012?
Your response must be concise. 6.84. What is the difference between the Balance of Payment (as % of service exports) of European Union in 2008 and the Balance of Payment (as % of service exports) of Venezuela in 2012?
Provide a short and direct response. -16.34. What is the difference between the Balance of Payment (as % of service exports) of Pacific island small states in 2008 and the Balance of Payment (as % of service exports) of Finland in 2012?
Give a very brief answer. 45.91. What is the difference between the Balance of Payment (as % of service exports) of Pacific island small states in 2008 and the Balance of Payment (as % of service exports) of Venezuela in 2012?
Your answer should be very brief. 22.73. What is the difference between the Balance of Payment (as % of service exports) in Finland in 2008 and the Balance of Payment (as % of service exports) in Venezuela in 2012?
Your response must be concise. -25.16. What is the difference between the Balance of Payment (as % of service exports) in European Union in 2009 and the Balance of Payment (as % of service exports) in Pacific island small states in 2010?
Make the answer very short. -43.67. What is the difference between the Balance of Payment (as % of service exports) in European Union in 2009 and the Balance of Payment (as % of service exports) in Finland in 2010?
Your response must be concise. 7.8. What is the difference between the Balance of Payment (as % of service exports) in European Union in 2009 and the Balance of Payment (as % of service exports) in Venezuela in 2010?
Provide a succinct answer. -18.23. What is the difference between the Balance of Payment (as % of service exports) in Pacific island small states in 2009 and the Balance of Payment (as % of service exports) in Finland in 2010?
Your answer should be very brief. 51.19. What is the difference between the Balance of Payment (as % of service exports) of Pacific island small states in 2009 and the Balance of Payment (as % of service exports) of Venezuela in 2010?
Offer a very short reply. 25.16. What is the difference between the Balance of Payment (as % of service exports) of Finland in 2009 and the Balance of Payment (as % of service exports) of Venezuela in 2010?
Offer a terse response. -26.85. What is the difference between the Balance of Payment (as % of service exports) in European Union in 2009 and the Balance of Payment (as % of service exports) in Pacific island small states in 2011?
Ensure brevity in your answer.  -42.28. What is the difference between the Balance of Payment (as % of service exports) in European Union in 2009 and the Balance of Payment (as % of service exports) in Finland in 2011?
Provide a short and direct response. 6.92. What is the difference between the Balance of Payment (as % of service exports) of European Union in 2009 and the Balance of Payment (as % of service exports) of Venezuela in 2011?
Your answer should be very brief. -15.49. What is the difference between the Balance of Payment (as % of service exports) in Pacific island small states in 2009 and the Balance of Payment (as % of service exports) in Finland in 2011?
Offer a very short reply. 50.31. What is the difference between the Balance of Payment (as % of service exports) in Pacific island small states in 2009 and the Balance of Payment (as % of service exports) in Venezuela in 2011?
Make the answer very short. 27.9. What is the difference between the Balance of Payment (as % of service exports) in Finland in 2009 and the Balance of Payment (as % of service exports) in Venezuela in 2011?
Offer a very short reply. -24.11. What is the difference between the Balance of Payment (as % of service exports) in European Union in 2009 and the Balance of Payment (as % of service exports) in Pacific island small states in 2012?
Make the answer very short. -41.25. What is the difference between the Balance of Payment (as % of service exports) of European Union in 2009 and the Balance of Payment (as % of service exports) of Finland in 2012?
Offer a terse response. 6.49. What is the difference between the Balance of Payment (as % of service exports) of European Union in 2009 and the Balance of Payment (as % of service exports) of Venezuela in 2012?
Provide a short and direct response. -16.69. What is the difference between the Balance of Payment (as % of service exports) of Pacific island small states in 2009 and the Balance of Payment (as % of service exports) of Finland in 2012?
Keep it short and to the point. 49.88. What is the difference between the Balance of Payment (as % of service exports) in Pacific island small states in 2009 and the Balance of Payment (as % of service exports) in Venezuela in 2012?
Ensure brevity in your answer.  26.7. What is the difference between the Balance of Payment (as % of service exports) of Finland in 2009 and the Balance of Payment (as % of service exports) of Venezuela in 2012?
Your answer should be compact. -25.32. What is the difference between the Balance of Payment (as % of service exports) of European Union in 2010 and the Balance of Payment (as % of service exports) of Pacific island small states in 2011?
Offer a very short reply. -43.41. What is the difference between the Balance of Payment (as % of service exports) in European Union in 2010 and the Balance of Payment (as % of service exports) in Finland in 2011?
Provide a succinct answer. 5.79. What is the difference between the Balance of Payment (as % of service exports) in European Union in 2010 and the Balance of Payment (as % of service exports) in Venezuela in 2011?
Make the answer very short. -16.62. What is the difference between the Balance of Payment (as % of service exports) in Pacific island small states in 2010 and the Balance of Payment (as % of service exports) in Finland in 2011?
Make the answer very short. 50.6. What is the difference between the Balance of Payment (as % of service exports) in Pacific island small states in 2010 and the Balance of Payment (as % of service exports) in Venezuela in 2011?
Your response must be concise. 28.18. What is the difference between the Balance of Payment (as % of service exports) of Finland in 2010 and the Balance of Payment (as % of service exports) of Venezuela in 2011?
Keep it short and to the point. -23.29. What is the difference between the Balance of Payment (as % of service exports) of European Union in 2010 and the Balance of Payment (as % of service exports) of Pacific island small states in 2012?
Keep it short and to the point. -42.38. What is the difference between the Balance of Payment (as % of service exports) of European Union in 2010 and the Balance of Payment (as % of service exports) of Finland in 2012?
Your response must be concise. 5.36. What is the difference between the Balance of Payment (as % of service exports) in European Union in 2010 and the Balance of Payment (as % of service exports) in Venezuela in 2012?
Give a very brief answer. -17.82. What is the difference between the Balance of Payment (as % of service exports) of Pacific island small states in 2010 and the Balance of Payment (as % of service exports) of Finland in 2012?
Keep it short and to the point. 50.16. What is the difference between the Balance of Payment (as % of service exports) of Pacific island small states in 2010 and the Balance of Payment (as % of service exports) of Venezuela in 2012?
Give a very brief answer. 26.98. What is the difference between the Balance of Payment (as % of service exports) of Finland in 2010 and the Balance of Payment (as % of service exports) of Venezuela in 2012?
Your answer should be compact. -24.49. What is the difference between the Balance of Payment (as % of service exports) in European Union in 2011 and the Balance of Payment (as % of service exports) in Pacific island small states in 2012?
Provide a short and direct response. -42.22. What is the difference between the Balance of Payment (as % of service exports) of European Union in 2011 and the Balance of Payment (as % of service exports) of Finland in 2012?
Your response must be concise. 5.52. What is the difference between the Balance of Payment (as % of service exports) in European Union in 2011 and the Balance of Payment (as % of service exports) in Venezuela in 2012?
Your answer should be compact. -17.66. What is the difference between the Balance of Payment (as % of service exports) of Pacific island small states in 2011 and the Balance of Payment (as % of service exports) of Finland in 2012?
Offer a very short reply. 48.77. What is the difference between the Balance of Payment (as % of service exports) in Pacific island small states in 2011 and the Balance of Payment (as % of service exports) in Venezuela in 2012?
Your answer should be very brief. 25.59. What is the difference between the Balance of Payment (as % of service exports) in Finland in 2011 and the Balance of Payment (as % of service exports) in Venezuela in 2012?
Your answer should be compact. -23.61. What is the average Balance of Payment (as % of service exports) of European Union per year?
Offer a very short reply. 21.82. What is the average Balance of Payment (as % of service exports) in Pacific island small states per year?
Make the answer very short. 60. What is the average Balance of Payment (as % of service exports) in Finland per year?
Ensure brevity in your answer.  15.27. What is the average Balance of Payment (as % of service exports) in Venezuela per year?
Ensure brevity in your answer.  44.19. In the year 2005, what is the difference between the Balance of Payment (as % of service exports) of European Union and Balance of Payment (as % of service exports) of Pacific island small states?
Your answer should be very brief. -27.47. In the year 2005, what is the difference between the Balance of Payment (as % of service exports) of European Union and Balance of Payment (as % of service exports) of Finland?
Keep it short and to the point. 6.42. In the year 2005, what is the difference between the Balance of Payment (as % of service exports) in European Union and Balance of Payment (as % of service exports) in Venezuela?
Your answer should be compact. -24.1. In the year 2005, what is the difference between the Balance of Payment (as % of service exports) in Pacific island small states and Balance of Payment (as % of service exports) in Finland?
Give a very brief answer. 33.88. In the year 2005, what is the difference between the Balance of Payment (as % of service exports) in Pacific island small states and Balance of Payment (as % of service exports) in Venezuela?
Provide a short and direct response. 3.37. In the year 2005, what is the difference between the Balance of Payment (as % of service exports) in Finland and Balance of Payment (as % of service exports) in Venezuela?
Offer a very short reply. -30.51. In the year 2006, what is the difference between the Balance of Payment (as % of service exports) in European Union and Balance of Payment (as % of service exports) in Pacific island small states?
Give a very brief answer. -32.06. In the year 2006, what is the difference between the Balance of Payment (as % of service exports) of European Union and Balance of Payment (as % of service exports) of Finland?
Give a very brief answer. 6.29. In the year 2006, what is the difference between the Balance of Payment (as % of service exports) of European Union and Balance of Payment (as % of service exports) of Venezuela?
Your answer should be very brief. -26.01. In the year 2006, what is the difference between the Balance of Payment (as % of service exports) in Pacific island small states and Balance of Payment (as % of service exports) in Finland?
Provide a succinct answer. 38.35. In the year 2006, what is the difference between the Balance of Payment (as % of service exports) of Pacific island small states and Balance of Payment (as % of service exports) of Venezuela?
Offer a very short reply. 6.06. In the year 2006, what is the difference between the Balance of Payment (as % of service exports) in Finland and Balance of Payment (as % of service exports) in Venezuela?
Your response must be concise. -32.29. In the year 2007, what is the difference between the Balance of Payment (as % of service exports) of European Union and Balance of Payment (as % of service exports) of Pacific island small states?
Provide a short and direct response. -32.57. In the year 2007, what is the difference between the Balance of Payment (as % of service exports) in European Union and Balance of Payment (as % of service exports) in Finland?
Offer a very short reply. 4.75. In the year 2007, what is the difference between the Balance of Payment (as % of service exports) of European Union and Balance of Payment (as % of service exports) of Venezuela?
Provide a short and direct response. -26.42. In the year 2007, what is the difference between the Balance of Payment (as % of service exports) in Pacific island small states and Balance of Payment (as % of service exports) in Finland?
Offer a very short reply. 37.31. In the year 2007, what is the difference between the Balance of Payment (as % of service exports) in Pacific island small states and Balance of Payment (as % of service exports) in Venezuela?
Offer a terse response. 6.14. In the year 2007, what is the difference between the Balance of Payment (as % of service exports) of Finland and Balance of Payment (as % of service exports) of Venezuela?
Ensure brevity in your answer.  -31.17. In the year 2008, what is the difference between the Balance of Payment (as % of service exports) of European Union and Balance of Payment (as % of service exports) of Pacific island small states?
Your answer should be compact. -39.07. In the year 2008, what is the difference between the Balance of Payment (as % of service exports) of European Union and Balance of Payment (as % of service exports) of Finland?
Your answer should be compact. 8.81. In the year 2008, what is the difference between the Balance of Payment (as % of service exports) in European Union and Balance of Payment (as % of service exports) in Venezuela?
Give a very brief answer. -25.49. In the year 2008, what is the difference between the Balance of Payment (as % of service exports) in Pacific island small states and Balance of Payment (as % of service exports) in Finland?
Offer a very short reply. 47.89. In the year 2008, what is the difference between the Balance of Payment (as % of service exports) of Pacific island small states and Balance of Payment (as % of service exports) of Venezuela?
Your answer should be very brief. 13.58. In the year 2008, what is the difference between the Balance of Payment (as % of service exports) of Finland and Balance of Payment (as % of service exports) of Venezuela?
Give a very brief answer. -34.31. In the year 2009, what is the difference between the Balance of Payment (as % of service exports) in European Union and Balance of Payment (as % of service exports) in Pacific island small states?
Keep it short and to the point. -43.39. In the year 2009, what is the difference between the Balance of Payment (as % of service exports) in European Union and Balance of Payment (as % of service exports) in Finland?
Your response must be concise. 8.63. In the year 2009, what is the difference between the Balance of Payment (as % of service exports) of European Union and Balance of Payment (as % of service exports) of Venezuela?
Your answer should be very brief. -22.86. In the year 2009, what is the difference between the Balance of Payment (as % of service exports) of Pacific island small states and Balance of Payment (as % of service exports) of Finland?
Your answer should be very brief. 52.02. In the year 2009, what is the difference between the Balance of Payment (as % of service exports) in Pacific island small states and Balance of Payment (as % of service exports) in Venezuela?
Provide a short and direct response. 20.53. In the year 2009, what is the difference between the Balance of Payment (as % of service exports) of Finland and Balance of Payment (as % of service exports) of Venezuela?
Your response must be concise. -31.48. In the year 2010, what is the difference between the Balance of Payment (as % of service exports) of European Union and Balance of Payment (as % of service exports) of Pacific island small states?
Your answer should be very brief. -44.81. In the year 2010, what is the difference between the Balance of Payment (as % of service exports) in European Union and Balance of Payment (as % of service exports) in Finland?
Provide a short and direct response. 6.66. In the year 2010, what is the difference between the Balance of Payment (as % of service exports) in European Union and Balance of Payment (as % of service exports) in Venezuela?
Your answer should be very brief. -19.36. In the year 2010, what is the difference between the Balance of Payment (as % of service exports) in Pacific island small states and Balance of Payment (as % of service exports) in Finland?
Offer a terse response. 51.47. In the year 2010, what is the difference between the Balance of Payment (as % of service exports) of Pacific island small states and Balance of Payment (as % of service exports) of Venezuela?
Your answer should be very brief. 25.45. In the year 2010, what is the difference between the Balance of Payment (as % of service exports) in Finland and Balance of Payment (as % of service exports) in Venezuela?
Keep it short and to the point. -26.02. In the year 2011, what is the difference between the Balance of Payment (as % of service exports) of European Union and Balance of Payment (as % of service exports) of Pacific island small states?
Provide a succinct answer. -43.25. In the year 2011, what is the difference between the Balance of Payment (as % of service exports) in European Union and Balance of Payment (as % of service exports) in Finland?
Provide a short and direct response. 5.95. In the year 2011, what is the difference between the Balance of Payment (as % of service exports) in European Union and Balance of Payment (as % of service exports) in Venezuela?
Offer a terse response. -16.46. In the year 2011, what is the difference between the Balance of Payment (as % of service exports) in Pacific island small states and Balance of Payment (as % of service exports) in Finland?
Your answer should be compact. 49.2. In the year 2011, what is the difference between the Balance of Payment (as % of service exports) in Pacific island small states and Balance of Payment (as % of service exports) in Venezuela?
Make the answer very short. 26.79. In the year 2011, what is the difference between the Balance of Payment (as % of service exports) in Finland and Balance of Payment (as % of service exports) in Venezuela?
Make the answer very short. -22.41. In the year 2012, what is the difference between the Balance of Payment (as % of service exports) in European Union and Balance of Payment (as % of service exports) in Pacific island small states?
Your answer should be very brief. -42.81. In the year 2012, what is the difference between the Balance of Payment (as % of service exports) of European Union and Balance of Payment (as % of service exports) of Finland?
Offer a very short reply. 4.93. In the year 2012, what is the difference between the Balance of Payment (as % of service exports) in European Union and Balance of Payment (as % of service exports) in Venezuela?
Provide a succinct answer. -18.25. In the year 2012, what is the difference between the Balance of Payment (as % of service exports) in Pacific island small states and Balance of Payment (as % of service exports) in Finland?
Keep it short and to the point. 47.74. In the year 2012, what is the difference between the Balance of Payment (as % of service exports) of Pacific island small states and Balance of Payment (as % of service exports) of Venezuela?
Your answer should be compact. 24.56. In the year 2012, what is the difference between the Balance of Payment (as % of service exports) of Finland and Balance of Payment (as % of service exports) of Venezuela?
Offer a very short reply. -23.18. What is the ratio of the Balance of Payment (as % of service exports) of European Union in 2005 to that in 2006?
Ensure brevity in your answer.  1.02. What is the ratio of the Balance of Payment (as % of service exports) of Pacific island small states in 2005 to that in 2006?
Offer a terse response. 0.93. What is the ratio of the Balance of Payment (as % of service exports) of Finland in 2005 to that in 2006?
Provide a succinct answer. 1.03. What is the ratio of the Balance of Payment (as % of service exports) in Venezuela in 2005 to that in 2006?
Provide a short and direct response. 0.97. What is the ratio of the Balance of Payment (as % of service exports) in European Union in 2005 to that in 2007?
Your answer should be compact. 1.07. What is the ratio of the Balance of Payment (as % of service exports) in Pacific island small states in 2005 to that in 2007?
Make the answer very short. 0.94. What is the ratio of the Balance of Payment (as % of service exports) of Finland in 2005 to that in 2007?
Your response must be concise. 1. What is the ratio of the Balance of Payment (as % of service exports) of Venezuela in 2005 to that in 2007?
Your answer should be compact. 0.99. What is the ratio of the Balance of Payment (as % of service exports) in European Union in 2005 to that in 2008?
Offer a terse response. 1.11. What is the ratio of the Balance of Payment (as % of service exports) in Pacific island small states in 2005 to that in 2008?
Give a very brief answer. 0.85. What is the ratio of the Balance of Payment (as % of service exports) in Finland in 2005 to that in 2008?
Offer a terse response. 1.36. What is the ratio of the Balance of Payment (as % of service exports) of Venezuela in 2005 to that in 2008?
Your answer should be very brief. 1.02. What is the ratio of the Balance of Payment (as % of service exports) in European Union in 2005 to that in 2009?
Provide a succinct answer. 1.12. What is the ratio of the Balance of Payment (as % of service exports) in Pacific island small states in 2005 to that in 2009?
Provide a succinct answer. 0.8. What is the ratio of the Balance of Payment (as % of service exports) in Finland in 2005 to that in 2009?
Your response must be concise. 1.38. What is the ratio of the Balance of Payment (as % of service exports) in Venezuela in 2005 to that in 2009?
Your response must be concise. 1.09. What is the ratio of the Balance of Payment (as % of service exports) in European Union in 2005 to that in 2010?
Offer a terse response. 1.19. What is the ratio of the Balance of Payment (as % of service exports) in Pacific island small states in 2005 to that in 2010?
Provide a short and direct response. 0.79. What is the ratio of the Balance of Payment (as % of service exports) in Finland in 2005 to that in 2010?
Keep it short and to the point. 1.3. What is the ratio of the Balance of Payment (as % of service exports) in Venezuela in 2005 to that in 2010?
Provide a succinct answer. 1.22. What is the ratio of the Balance of Payment (as % of service exports) in European Union in 2005 to that in 2011?
Make the answer very short. 1.18. What is the ratio of the Balance of Payment (as % of service exports) in Pacific island small states in 2005 to that in 2011?
Your answer should be compact. 0.81. What is the ratio of the Balance of Payment (as % of service exports) of Finland in 2005 to that in 2011?
Offer a very short reply. 1.22. What is the ratio of the Balance of Payment (as % of service exports) of Venezuela in 2005 to that in 2011?
Provide a succinct answer. 1.3. What is the ratio of the Balance of Payment (as % of service exports) in European Union in 2005 to that in 2012?
Offer a terse response. 1.21. What is the ratio of the Balance of Payment (as % of service exports) in Pacific island small states in 2005 to that in 2012?
Offer a very short reply. 0.82. What is the ratio of the Balance of Payment (as % of service exports) in Finland in 2005 to that in 2012?
Provide a short and direct response. 1.18. What is the ratio of the Balance of Payment (as % of service exports) in Venezuela in 2005 to that in 2012?
Your answer should be compact. 1.26. What is the ratio of the Balance of Payment (as % of service exports) of European Union in 2006 to that in 2007?
Make the answer very short. 1.05. What is the ratio of the Balance of Payment (as % of service exports) of Pacific island small states in 2006 to that in 2007?
Ensure brevity in your answer.  1.01. What is the ratio of the Balance of Payment (as % of service exports) of Finland in 2006 to that in 2007?
Give a very brief answer. 0.97. What is the ratio of the Balance of Payment (as % of service exports) in Venezuela in 2006 to that in 2007?
Offer a very short reply. 1.01. What is the ratio of the Balance of Payment (as % of service exports) of European Union in 2006 to that in 2008?
Offer a terse response. 1.08. What is the ratio of the Balance of Payment (as % of service exports) in Pacific island small states in 2006 to that in 2008?
Keep it short and to the point. 0.91. What is the ratio of the Balance of Payment (as % of service exports) of Finland in 2006 to that in 2008?
Provide a succinct answer. 1.33. What is the ratio of the Balance of Payment (as % of service exports) of Venezuela in 2006 to that in 2008?
Your response must be concise. 1.05. What is the ratio of the Balance of Payment (as % of service exports) of European Union in 2006 to that in 2009?
Your response must be concise. 1.1. What is the ratio of the Balance of Payment (as % of service exports) in Pacific island small states in 2006 to that in 2009?
Provide a succinct answer. 0.86. What is the ratio of the Balance of Payment (as % of service exports) of Finland in 2006 to that in 2009?
Make the answer very short. 1.34. What is the ratio of the Balance of Payment (as % of service exports) of Venezuela in 2006 to that in 2009?
Your answer should be compact. 1.12. What is the ratio of the Balance of Payment (as % of service exports) in European Union in 2006 to that in 2010?
Provide a succinct answer. 1.16. What is the ratio of the Balance of Payment (as % of service exports) in Pacific island small states in 2006 to that in 2010?
Make the answer very short. 0.85. What is the ratio of the Balance of Payment (as % of service exports) of Finland in 2006 to that in 2010?
Offer a terse response. 1.26. What is the ratio of the Balance of Payment (as % of service exports) of Venezuela in 2006 to that in 2010?
Your answer should be very brief. 1.25. What is the ratio of the Balance of Payment (as % of service exports) of European Union in 2006 to that in 2011?
Your answer should be compact. 1.15. What is the ratio of the Balance of Payment (as % of service exports) of Pacific island small states in 2006 to that in 2011?
Give a very brief answer. 0.87. What is the ratio of the Balance of Payment (as % of service exports) of Finland in 2006 to that in 2011?
Your response must be concise. 1.19. What is the ratio of the Balance of Payment (as % of service exports) of Venezuela in 2006 to that in 2011?
Provide a short and direct response. 1.34. What is the ratio of the Balance of Payment (as % of service exports) of European Union in 2006 to that in 2012?
Ensure brevity in your answer.  1.18. What is the ratio of the Balance of Payment (as % of service exports) in Pacific island small states in 2006 to that in 2012?
Keep it short and to the point. 0.89. What is the ratio of the Balance of Payment (as % of service exports) of Finland in 2006 to that in 2012?
Your answer should be very brief. 1.15. What is the ratio of the Balance of Payment (as % of service exports) in Venezuela in 2006 to that in 2012?
Offer a terse response. 1.3. What is the ratio of the Balance of Payment (as % of service exports) of European Union in 2007 to that in 2008?
Provide a succinct answer. 1.03. What is the ratio of the Balance of Payment (as % of service exports) in Pacific island small states in 2007 to that in 2008?
Keep it short and to the point. 0.9. What is the ratio of the Balance of Payment (as % of service exports) of Finland in 2007 to that in 2008?
Your response must be concise. 1.36. What is the ratio of the Balance of Payment (as % of service exports) of Venezuela in 2007 to that in 2008?
Your answer should be compact. 1.03. What is the ratio of the Balance of Payment (as % of service exports) in European Union in 2007 to that in 2009?
Your answer should be very brief. 1.05. What is the ratio of the Balance of Payment (as % of service exports) of Pacific island small states in 2007 to that in 2009?
Provide a succinct answer. 0.85. What is the ratio of the Balance of Payment (as % of service exports) in Finland in 2007 to that in 2009?
Give a very brief answer. 1.38. What is the ratio of the Balance of Payment (as % of service exports) of Venezuela in 2007 to that in 2009?
Offer a very short reply. 1.1. What is the ratio of the Balance of Payment (as % of service exports) of European Union in 2007 to that in 2010?
Provide a short and direct response. 1.11. What is the ratio of the Balance of Payment (as % of service exports) in Pacific island small states in 2007 to that in 2010?
Your response must be concise. 0.85. What is the ratio of the Balance of Payment (as % of service exports) in Finland in 2007 to that in 2010?
Offer a very short reply. 1.3. What is the ratio of the Balance of Payment (as % of service exports) in Venezuela in 2007 to that in 2010?
Make the answer very short. 1.23. What is the ratio of the Balance of Payment (as % of service exports) of European Union in 2007 to that in 2011?
Keep it short and to the point. 1.1. What is the ratio of the Balance of Payment (as % of service exports) in Pacific island small states in 2007 to that in 2011?
Your answer should be compact. 0.86. What is the ratio of the Balance of Payment (as % of service exports) of Finland in 2007 to that in 2011?
Keep it short and to the point. 1.22. What is the ratio of the Balance of Payment (as % of service exports) in Venezuela in 2007 to that in 2011?
Give a very brief answer. 1.32. What is the ratio of the Balance of Payment (as % of service exports) in European Union in 2007 to that in 2012?
Your answer should be very brief. 1.13. What is the ratio of the Balance of Payment (as % of service exports) in Pacific island small states in 2007 to that in 2012?
Offer a terse response. 0.88. What is the ratio of the Balance of Payment (as % of service exports) in Finland in 2007 to that in 2012?
Keep it short and to the point. 1.18. What is the ratio of the Balance of Payment (as % of service exports) in Venezuela in 2007 to that in 2012?
Ensure brevity in your answer.  1.28. What is the ratio of the Balance of Payment (as % of service exports) of European Union in 2008 to that in 2009?
Provide a short and direct response. 1.02. What is the ratio of the Balance of Payment (as % of service exports) in Pacific island small states in 2008 to that in 2009?
Make the answer very short. 0.94. What is the ratio of the Balance of Payment (as % of service exports) of Finland in 2008 to that in 2009?
Offer a very short reply. 1.01. What is the ratio of the Balance of Payment (as % of service exports) in Venezuela in 2008 to that in 2009?
Keep it short and to the point. 1.07. What is the ratio of the Balance of Payment (as % of service exports) in European Union in 2008 to that in 2010?
Provide a short and direct response. 1.07. What is the ratio of the Balance of Payment (as % of service exports) of Pacific island small states in 2008 to that in 2010?
Your answer should be compact. 0.93. What is the ratio of the Balance of Payment (as % of service exports) in Finland in 2008 to that in 2010?
Make the answer very short. 0.95. What is the ratio of the Balance of Payment (as % of service exports) of Venezuela in 2008 to that in 2010?
Provide a succinct answer. 1.19. What is the ratio of the Balance of Payment (as % of service exports) of European Union in 2008 to that in 2011?
Provide a short and direct response. 1.06. What is the ratio of the Balance of Payment (as % of service exports) in Pacific island small states in 2008 to that in 2011?
Keep it short and to the point. 0.96. What is the ratio of the Balance of Payment (as % of service exports) of Finland in 2008 to that in 2011?
Your answer should be very brief. 0.89. What is the ratio of the Balance of Payment (as % of service exports) of Venezuela in 2008 to that in 2011?
Your answer should be very brief. 1.28. What is the ratio of the Balance of Payment (as % of service exports) in European Union in 2008 to that in 2012?
Your answer should be compact. 1.1. What is the ratio of the Balance of Payment (as % of service exports) in Pacific island small states in 2008 to that in 2012?
Your answer should be very brief. 0.97. What is the ratio of the Balance of Payment (as % of service exports) in Finland in 2008 to that in 2012?
Your answer should be very brief. 0.87. What is the ratio of the Balance of Payment (as % of service exports) of Venezuela in 2008 to that in 2012?
Provide a succinct answer. 1.24. What is the ratio of the Balance of Payment (as % of service exports) of European Union in 2009 to that in 2010?
Ensure brevity in your answer.  1.06. What is the ratio of the Balance of Payment (as % of service exports) of Pacific island small states in 2009 to that in 2010?
Provide a short and direct response. 1. What is the ratio of the Balance of Payment (as % of service exports) of Finland in 2009 to that in 2010?
Give a very brief answer. 0.94. What is the ratio of the Balance of Payment (as % of service exports) of Venezuela in 2009 to that in 2010?
Keep it short and to the point. 1.12. What is the ratio of the Balance of Payment (as % of service exports) in European Union in 2009 to that in 2011?
Make the answer very short. 1.05. What is the ratio of the Balance of Payment (as % of service exports) in Pacific island small states in 2009 to that in 2011?
Provide a succinct answer. 1.02. What is the ratio of the Balance of Payment (as % of service exports) of Finland in 2009 to that in 2011?
Offer a terse response. 0.88. What is the ratio of the Balance of Payment (as % of service exports) of Venezuela in 2009 to that in 2011?
Keep it short and to the point. 1.2. What is the ratio of the Balance of Payment (as % of service exports) of European Union in 2009 to that in 2012?
Give a very brief answer. 1.08. What is the ratio of the Balance of Payment (as % of service exports) in Pacific island small states in 2009 to that in 2012?
Keep it short and to the point. 1.03. What is the ratio of the Balance of Payment (as % of service exports) in Finland in 2009 to that in 2012?
Provide a succinct answer. 0.86. What is the ratio of the Balance of Payment (as % of service exports) of Venezuela in 2009 to that in 2012?
Ensure brevity in your answer.  1.16. What is the ratio of the Balance of Payment (as % of service exports) of European Union in 2010 to that in 2011?
Your response must be concise. 0.99. What is the ratio of the Balance of Payment (as % of service exports) in Pacific island small states in 2010 to that in 2011?
Provide a succinct answer. 1.02. What is the ratio of the Balance of Payment (as % of service exports) of Finland in 2010 to that in 2011?
Offer a very short reply. 0.94. What is the ratio of the Balance of Payment (as % of service exports) in Venezuela in 2010 to that in 2011?
Your answer should be very brief. 1.07. What is the ratio of the Balance of Payment (as % of service exports) in European Union in 2010 to that in 2012?
Your answer should be very brief. 1.02. What is the ratio of the Balance of Payment (as % of service exports) in Pacific island small states in 2010 to that in 2012?
Your answer should be very brief. 1.04. What is the ratio of the Balance of Payment (as % of service exports) in Finland in 2010 to that in 2012?
Provide a short and direct response. 0.91. What is the ratio of the Balance of Payment (as % of service exports) of Venezuela in 2010 to that in 2012?
Your answer should be compact. 1.04. What is the ratio of the Balance of Payment (as % of service exports) of European Union in 2011 to that in 2012?
Offer a very short reply. 1.03. What is the ratio of the Balance of Payment (as % of service exports) of Pacific island small states in 2011 to that in 2012?
Offer a very short reply. 1.02. What is the ratio of the Balance of Payment (as % of service exports) of Finland in 2011 to that in 2012?
Your answer should be very brief. 0.97. What is the ratio of the Balance of Payment (as % of service exports) of Venezuela in 2011 to that in 2012?
Give a very brief answer. 0.97. What is the difference between the highest and the second highest Balance of Payment (as % of service exports) of European Union?
Keep it short and to the point. 0.59. What is the difference between the highest and the second highest Balance of Payment (as % of service exports) in Pacific island small states?
Your answer should be compact. 0.28. What is the difference between the highest and the second highest Balance of Payment (as % of service exports) of Finland?
Give a very brief answer. 0.01. What is the difference between the highest and the second highest Balance of Payment (as % of service exports) in Venezuela?
Your answer should be compact. 0.65. What is the difference between the highest and the lowest Balance of Payment (as % of service exports) of European Union?
Provide a succinct answer. 4.24. What is the difference between the highest and the lowest Balance of Payment (as % of service exports) of Pacific island small states?
Your answer should be very brief. 13.53. What is the difference between the highest and the lowest Balance of Payment (as % of service exports) of Finland?
Your answer should be compact. 4.9. What is the difference between the highest and the lowest Balance of Payment (as % of service exports) in Venezuela?
Offer a terse response. 12.61. 